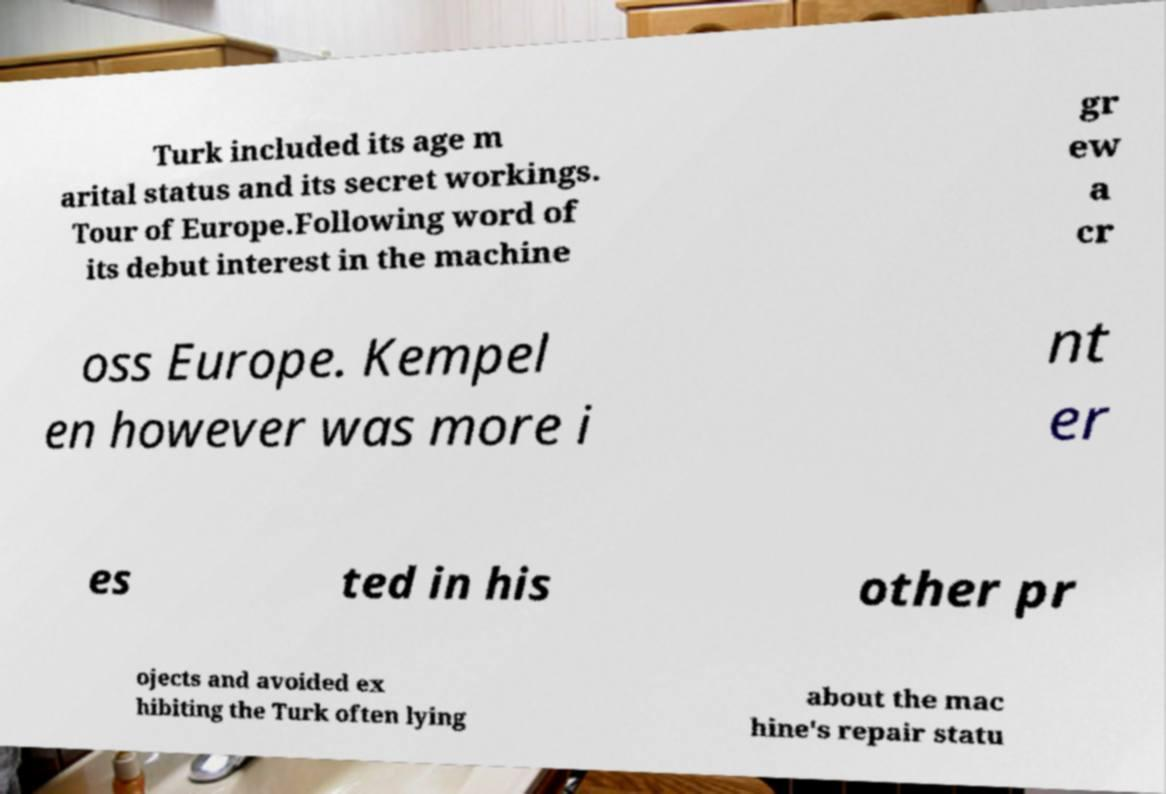For documentation purposes, I need the text within this image transcribed. Could you provide that? Turk included its age m arital status and its secret workings. Tour of Europe.Following word of its debut interest in the machine gr ew a cr oss Europe. Kempel en however was more i nt er es ted in his other pr ojects and avoided ex hibiting the Turk often lying about the mac hine's repair statu 